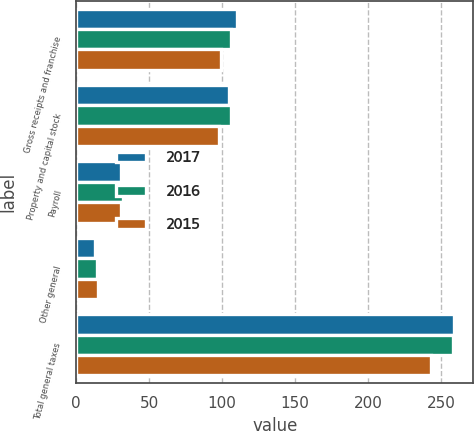Convert chart to OTSL. <chart><loc_0><loc_0><loc_500><loc_500><stacked_bar_chart><ecel><fcel>Gross receipts and franchise<fcel>Property and capital stock<fcel>Payroll<fcel>Other general<fcel>Total general taxes<nl><fcel>2017<fcel>110<fcel>105<fcel>31<fcel>13<fcel>259<nl><fcel>2016<fcel>106<fcel>106<fcel>32<fcel>14<fcel>258<nl><fcel>2015<fcel>99<fcel>98<fcel>31<fcel>15<fcel>243<nl></chart> 